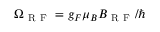Convert formula to latex. <formula><loc_0><loc_0><loc_500><loc_500>\Omega _ { R F } = g _ { F } \mu _ { B } B _ { R F } / \hbar</formula> 